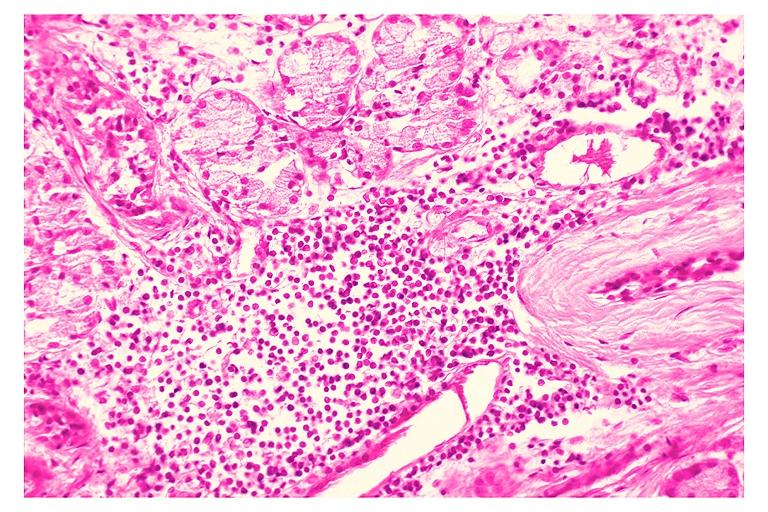does sugar coated show chronic sialadenitis?
Answer the question using a single word or phrase. No 